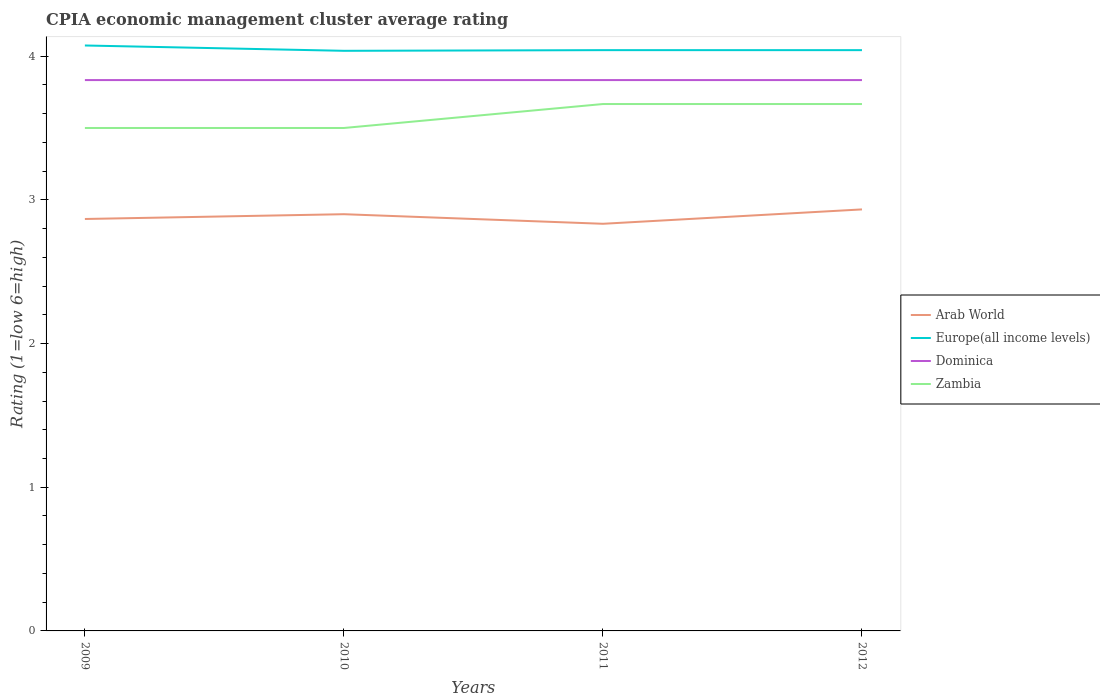How many different coloured lines are there?
Provide a short and direct response. 4. Does the line corresponding to Arab World intersect with the line corresponding to Europe(all income levels)?
Give a very brief answer. No. Across all years, what is the maximum CPIA rating in Europe(all income levels)?
Keep it short and to the point. 4.04. What is the total CPIA rating in Europe(all income levels) in the graph?
Your response must be concise. -0. What is the difference between the highest and the second highest CPIA rating in Arab World?
Make the answer very short. 0.1. Is the CPIA rating in Zambia strictly greater than the CPIA rating in Europe(all income levels) over the years?
Provide a succinct answer. Yes. How many years are there in the graph?
Your answer should be very brief. 4. Does the graph contain grids?
Provide a succinct answer. No. How many legend labels are there?
Your answer should be compact. 4. What is the title of the graph?
Your answer should be very brief. CPIA economic management cluster average rating. Does "Malaysia" appear as one of the legend labels in the graph?
Ensure brevity in your answer.  No. What is the label or title of the X-axis?
Your response must be concise. Years. What is the label or title of the Y-axis?
Offer a terse response. Rating (1=low 6=high). What is the Rating (1=low 6=high) in Arab World in 2009?
Provide a succinct answer. 2.87. What is the Rating (1=low 6=high) of Europe(all income levels) in 2009?
Give a very brief answer. 4.07. What is the Rating (1=low 6=high) of Dominica in 2009?
Your response must be concise. 3.83. What is the Rating (1=low 6=high) in Arab World in 2010?
Your answer should be very brief. 2.9. What is the Rating (1=low 6=high) in Europe(all income levels) in 2010?
Provide a succinct answer. 4.04. What is the Rating (1=low 6=high) of Dominica in 2010?
Provide a short and direct response. 3.83. What is the Rating (1=low 6=high) of Arab World in 2011?
Offer a very short reply. 2.83. What is the Rating (1=low 6=high) of Europe(all income levels) in 2011?
Ensure brevity in your answer.  4.04. What is the Rating (1=low 6=high) in Dominica in 2011?
Your answer should be compact. 3.83. What is the Rating (1=low 6=high) of Zambia in 2011?
Offer a very short reply. 3.67. What is the Rating (1=low 6=high) of Arab World in 2012?
Offer a terse response. 2.93. What is the Rating (1=low 6=high) of Europe(all income levels) in 2012?
Make the answer very short. 4.04. What is the Rating (1=low 6=high) of Dominica in 2012?
Keep it short and to the point. 3.83. What is the Rating (1=low 6=high) of Zambia in 2012?
Offer a terse response. 3.67. Across all years, what is the maximum Rating (1=low 6=high) in Arab World?
Keep it short and to the point. 2.93. Across all years, what is the maximum Rating (1=low 6=high) in Europe(all income levels)?
Your answer should be compact. 4.07. Across all years, what is the maximum Rating (1=low 6=high) of Dominica?
Provide a succinct answer. 3.83. Across all years, what is the maximum Rating (1=low 6=high) of Zambia?
Offer a very short reply. 3.67. Across all years, what is the minimum Rating (1=low 6=high) in Arab World?
Your answer should be very brief. 2.83. Across all years, what is the minimum Rating (1=low 6=high) of Europe(all income levels)?
Your answer should be very brief. 4.04. Across all years, what is the minimum Rating (1=low 6=high) of Dominica?
Make the answer very short. 3.83. Across all years, what is the minimum Rating (1=low 6=high) in Zambia?
Make the answer very short. 3.5. What is the total Rating (1=low 6=high) of Arab World in the graph?
Ensure brevity in your answer.  11.53. What is the total Rating (1=low 6=high) in Europe(all income levels) in the graph?
Provide a short and direct response. 16.19. What is the total Rating (1=low 6=high) of Dominica in the graph?
Ensure brevity in your answer.  15.33. What is the total Rating (1=low 6=high) of Zambia in the graph?
Provide a succinct answer. 14.33. What is the difference between the Rating (1=low 6=high) of Arab World in 2009 and that in 2010?
Your answer should be very brief. -0.03. What is the difference between the Rating (1=low 6=high) of Europe(all income levels) in 2009 and that in 2010?
Ensure brevity in your answer.  0.04. What is the difference between the Rating (1=low 6=high) in Dominica in 2009 and that in 2010?
Offer a terse response. 0. What is the difference between the Rating (1=low 6=high) of Zambia in 2009 and that in 2010?
Give a very brief answer. 0. What is the difference between the Rating (1=low 6=high) in Arab World in 2009 and that in 2011?
Give a very brief answer. 0.03. What is the difference between the Rating (1=low 6=high) of Europe(all income levels) in 2009 and that in 2011?
Make the answer very short. 0.03. What is the difference between the Rating (1=low 6=high) of Dominica in 2009 and that in 2011?
Your answer should be compact. 0. What is the difference between the Rating (1=low 6=high) in Arab World in 2009 and that in 2012?
Make the answer very short. -0.07. What is the difference between the Rating (1=low 6=high) of Europe(all income levels) in 2009 and that in 2012?
Provide a succinct answer. 0.03. What is the difference between the Rating (1=low 6=high) of Dominica in 2009 and that in 2012?
Give a very brief answer. 0. What is the difference between the Rating (1=low 6=high) of Arab World in 2010 and that in 2011?
Offer a very short reply. 0.07. What is the difference between the Rating (1=low 6=high) of Europe(all income levels) in 2010 and that in 2011?
Offer a very short reply. -0. What is the difference between the Rating (1=low 6=high) of Zambia in 2010 and that in 2011?
Give a very brief answer. -0.17. What is the difference between the Rating (1=low 6=high) of Arab World in 2010 and that in 2012?
Provide a succinct answer. -0.03. What is the difference between the Rating (1=low 6=high) in Europe(all income levels) in 2010 and that in 2012?
Ensure brevity in your answer.  -0. What is the difference between the Rating (1=low 6=high) of Dominica in 2010 and that in 2012?
Give a very brief answer. 0. What is the difference between the Rating (1=low 6=high) in Zambia in 2010 and that in 2012?
Provide a succinct answer. -0.17. What is the difference between the Rating (1=low 6=high) in Arab World in 2011 and that in 2012?
Your response must be concise. -0.1. What is the difference between the Rating (1=low 6=high) in Europe(all income levels) in 2011 and that in 2012?
Your answer should be compact. 0. What is the difference between the Rating (1=low 6=high) in Arab World in 2009 and the Rating (1=low 6=high) in Europe(all income levels) in 2010?
Keep it short and to the point. -1.17. What is the difference between the Rating (1=low 6=high) of Arab World in 2009 and the Rating (1=low 6=high) of Dominica in 2010?
Offer a terse response. -0.97. What is the difference between the Rating (1=low 6=high) in Arab World in 2009 and the Rating (1=low 6=high) in Zambia in 2010?
Provide a succinct answer. -0.63. What is the difference between the Rating (1=low 6=high) of Europe(all income levels) in 2009 and the Rating (1=low 6=high) of Dominica in 2010?
Provide a short and direct response. 0.24. What is the difference between the Rating (1=low 6=high) in Europe(all income levels) in 2009 and the Rating (1=low 6=high) in Zambia in 2010?
Your response must be concise. 0.57. What is the difference between the Rating (1=low 6=high) of Arab World in 2009 and the Rating (1=low 6=high) of Europe(all income levels) in 2011?
Give a very brief answer. -1.18. What is the difference between the Rating (1=low 6=high) in Arab World in 2009 and the Rating (1=low 6=high) in Dominica in 2011?
Your answer should be compact. -0.97. What is the difference between the Rating (1=low 6=high) in Arab World in 2009 and the Rating (1=low 6=high) in Zambia in 2011?
Provide a succinct answer. -0.8. What is the difference between the Rating (1=low 6=high) of Europe(all income levels) in 2009 and the Rating (1=low 6=high) of Dominica in 2011?
Ensure brevity in your answer.  0.24. What is the difference between the Rating (1=low 6=high) of Europe(all income levels) in 2009 and the Rating (1=low 6=high) of Zambia in 2011?
Ensure brevity in your answer.  0.41. What is the difference between the Rating (1=low 6=high) of Arab World in 2009 and the Rating (1=low 6=high) of Europe(all income levels) in 2012?
Provide a short and direct response. -1.18. What is the difference between the Rating (1=low 6=high) in Arab World in 2009 and the Rating (1=low 6=high) in Dominica in 2012?
Your response must be concise. -0.97. What is the difference between the Rating (1=low 6=high) in Europe(all income levels) in 2009 and the Rating (1=low 6=high) in Dominica in 2012?
Keep it short and to the point. 0.24. What is the difference between the Rating (1=low 6=high) of Europe(all income levels) in 2009 and the Rating (1=low 6=high) of Zambia in 2012?
Provide a succinct answer. 0.41. What is the difference between the Rating (1=low 6=high) in Dominica in 2009 and the Rating (1=low 6=high) in Zambia in 2012?
Provide a succinct answer. 0.17. What is the difference between the Rating (1=low 6=high) of Arab World in 2010 and the Rating (1=low 6=high) of Europe(all income levels) in 2011?
Your answer should be very brief. -1.14. What is the difference between the Rating (1=low 6=high) in Arab World in 2010 and the Rating (1=low 6=high) in Dominica in 2011?
Ensure brevity in your answer.  -0.93. What is the difference between the Rating (1=low 6=high) of Arab World in 2010 and the Rating (1=low 6=high) of Zambia in 2011?
Make the answer very short. -0.77. What is the difference between the Rating (1=low 6=high) of Europe(all income levels) in 2010 and the Rating (1=low 6=high) of Dominica in 2011?
Ensure brevity in your answer.  0.2. What is the difference between the Rating (1=low 6=high) of Europe(all income levels) in 2010 and the Rating (1=low 6=high) of Zambia in 2011?
Make the answer very short. 0.37. What is the difference between the Rating (1=low 6=high) of Dominica in 2010 and the Rating (1=low 6=high) of Zambia in 2011?
Make the answer very short. 0.17. What is the difference between the Rating (1=low 6=high) in Arab World in 2010 and the Rating (1=low 6=high) in Europe(all income levels) in 2012?
Your answer should be compact. -1.14. What is the difference between the Rating (1=low 6=high) in Arab World in 2010 and the Rating (1=low 6=high) in Dominica in 2012?
Provide a short and direct response. -0.93. What is the difference between the Rating (1=low 6=high) of Arab World in 2010 and the Rating (1=low 6=high) of Zambia in 2012?
Your response must be concise. -0.77. What is the difference between the Rating (1=low 6=high) in Europe(all income levels) in 2010 and the Rating (1=low 6=high) in Dominica in 2012?
Give a very brief answer. 0.2. What is the difference between the Rating (1=low 6=high) in Europe(all income levels) in 2010 and the Rating (1=low 6=high) in Zambia in 2012?
Your answer should be very brief. 0.37. What is the difference between the Rating (1=low 6=high) of Dominica in 2010 and the Rating (1=low 6=high) of Zambia in 2012?
Give a very brief answer. 0.17. What is the difference between the Rating (1=low 6=high) in Arab World in 2011 and the Rating (1=low 6=high) in Europe(all income levels) in 2012?
Give a very brief answer. -1.21. What is the difference between the Rating (1=low 6=high) of Arab World in 2011 and the Rating (1=low 6=high) of Zambia in 2012?
Give a very brief answer. -0.83. What is the difference between the Rating (1=low 6=high) of Europe(all income levels) in 2011 and the Rating (1=low 6=high) of Dominica in 2012?
Ensure brevity in your answer.  0.21. What is the difference between the Rating (1=low 6=high) in Dominica in 2011 and the Rating (1=low 6=high) in Zambia in 2012?
Keep it short and to the point. 0.17. What is the average Rating (1=low 6=high) of Arab World per year?
Provide a short and direct response. 2.88. What is the average Rating (1=low 6=high) of Europe(all income levels) per year?
Give a very brief answer. 4.05. What is the average Rating (1=low 6=high) in Dominica per year?
Give a very brief answer. 3.83. What is the average Rating (1=low 6=high) of Zambia per year?
Offer a terse response. 3.58. In the year 2009, what is the difference between the Rating (1=low 6=high) of Arab World and Rating (1=low 6=high) of Europe(all income levels)?
Ensure brevity in your answer.  -1.21. In the year 2009, what is the difference between the Rating (1=low 6=high) in Arab World and Rating (1=low 6=high) in Dominica?
Provide a succinct answer. -0.97. In the year 2009, what is the difference between the Rating (1=low 6=high) in Arab World and Rating (1=low 6=high) in Zambia?
Your answer should be very brief. -0.63. In the year 2009, what is the difference between the Rating (1=low 6=high) of Europe(all income levels) and Rating (1=low 6=high) of Dominica?
Provide a short and direct response. 0.24. In the year 2009, what is the difference between the Rating (1=low 6=high) in Europe(all income levels) and Rating (1=low 6=high) in Zambia?
Provide a succinct answer. 0.57. In the year 2010, what is the difference between the Rating (1=low 6=high) in Arab World and Rating (1=low 6=high) in Europe(all income levels)?
Your response must be concise. -1.14. In the year 2010, what is the difference between the Rating (1=low 6=high) of Arab World and Rating (1=low 6=high) of Dominica?
Your answer should be compact. -0.93. In the year 2010, what is the difference between the Rating (1=low 6=high) of Arab World and Rating (1=low 6=high) of Zambia?
Your answer should be very brief. -0.6. In the year 2010, what is the difference between the Rating (1=low 6=high) of Europe(all income levels) and Rating (1=low 6=high) of Dominica?
Make the answer very short. 0.2. In the year 2010, what is the difference between the Rating (1=low 6=high) in Europe(all income levels) and Rating (1=low 6=high) in Zambia?
Offer a terse response. 0.54. In the year 2011, what is the difference between the Rating (1=low 6=high) of Arab World and Rating (1=low 6=high) of Europe(all income levels)?
Provide a succinct answer. -1.21. In the year 2011, what is the difference between the Rating (1=low 6=high) of Arab World and Rating (1=low 6=high) of Dominica?
Make the answer very short. -1. In the year 2011, what is the difference between the Rating (1=low 6=high) of Europe(all income levels) and Rating (1=low 6=high) of Dominica?
Ensure brevity in your answer.  0.21. In the year 2011, what is the difference between the Rating (1=low 6=high) in Dominica and Rating (1=low 6=high) in Zambia?
Offer a very short reply. 0.17. In the year 2012, what is the difference between the Rating (1=low 6=high) in Arab World and Rating (1=low 6=high) in Europe(all income levels)?
Your response must be concise. -1.11. In the year 2012, what is the difference between the Rating (1=low 6=high) in Arab World and Rating (1=low 6=high) in Zambia?
Your response must be concise. -0.73. In the year 2012, what is the difference between the Rating (1=low 6=high) of Europe(all income levels) and Rating (1=low 6=high) of Dominica?
Provide a succinct answer. 0.21. In the year 2012, what is the difference between the Rating (1=low 6=high) in Dominica and Rating (1=low 6=high) in Zambia?
Provide a short and direct response. 0.17. What is the ratio of the Rating (1=low 6=high) of Europe(all income levels) in 2009 to that in 2010?
Make the answer very short. 1.01. What is the ratio of the Rating (1=low 6=high) of Arab World in 2009 to that in 2011?
Make the answer very short. 1.01. What is the ratio of the Rating (1=low 6=high) in Dominica in 2009 to that in 2011?
Make the answer very short. 1. What is the ratio of the Rating (1=low 6=high) of Zambia in 2009 to that in 2011?
Give a very brief answer. 0.95. What is the ratio of the Rating (1=low 6=high) in Arab World in 2009 to that in 2012?
Provide a short and direct response. 0.98. What is the ratio of the Rating (1=low 6=high) of Europe(all income levels) in 2009 to that in 2012?
Your answer should be very brief. 1.01. What is the ratio of the Rating (1=low 6=high) in Dominica in 2009 to that in 2012?
Ensure brevity in your answer.  1. What is the ratio of the Rating (1=low 6=high) in Zambia in 2009 to that in 2012?
Give a very brief answer. 0.95. What is the ratio of the Rating (1=low 6=high) of Arab World in 2010 to that in 2011?
Give a very brief answer. 1.02. What is the ratio of the Rating (1=low 6=high) of Europe(all income levels) in 2010 to that in 2011?
Ensure brevity in your answer.  1. What is the ratio of the Rating (1=low 6=high) of Zambia in 2010 to that in 2011?
Provide a short and direct response. 0.95. What is the ratio of the Rating (1=low 6=high) of Zambia in 2010 to that in 2012?
Your answer should be compact. 0.95. What is the ratio of the Rating (1=low 6=high) of Arab World in 2011 to that in 2012?
Offer a very short reply. 0.97. What is the ratio of the Rating (1=low 6=high) of Europe(all income levels) in 2011 to that in 2012?
Offer a terse response. 1. What is the ratio of the Rating (1=low 6=high) of Dominica in 2011 to that in 2012?
Your answer should be compact. 1. What is the ratio of the Rating (1=low 6=high) of Zambia in 2011 to that in 2012?
Provide a short and direct response. 1. What is the difference between the highest and the second highest Rating (1=low 6=high) of Arab World?
Ensure brevity in your answer.  0.03. What is the difference between the highest and the second highest Rating (1=low 6=high) in Europe(all income levels)?
Your response must be concise. 0.03. What is the difference between the highest and the second highest Rating (1=low 6=high) of Dominica?
Make the answer very short. 0. What is the difference between the highest and the second highest Rating (1=low 6=high) in Zambia?
Provide a succinct answer. 0. What is the difference between the highest and the lowest Rating (1=low 6=high) in Europe(all income levels)?
Provide a succinct answer. 0.04. What is the difference between the highest and the lowest Rating (1=low 6=high) of Zambia?
Provide a short and direct response. 0.17. 